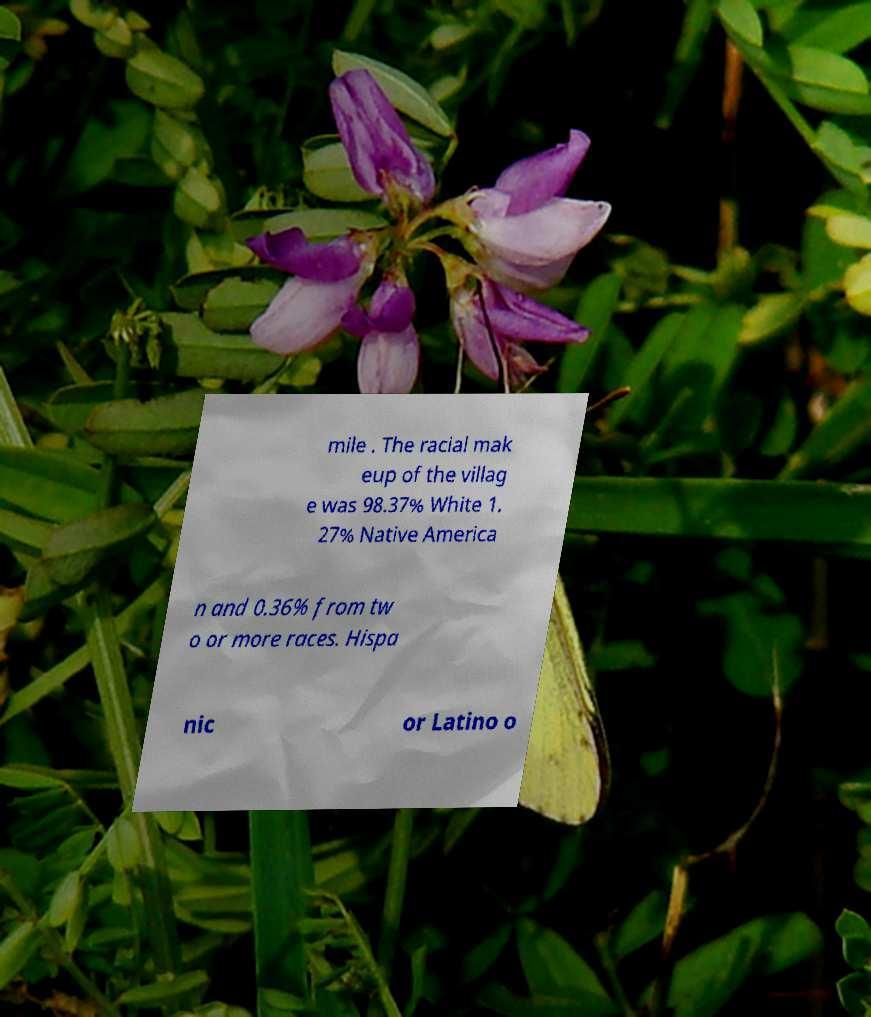There's text embedded in this image that I need extracted. Can you transcribe it verbatim? mile . The racial mak eup of the villag e was 98.37% White 1. 27% Native America n and 0.36% from tw o or more races. Hispa nic or Latino o 